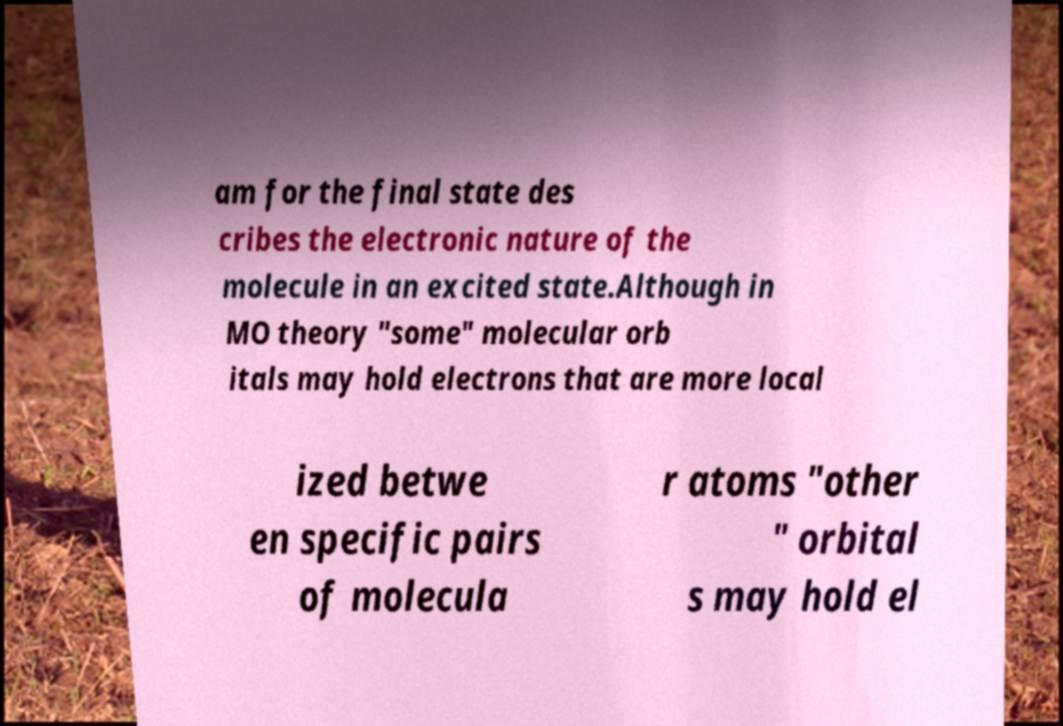Could you extract and type out the text from this image? am for the final state des cribes the electronic nature of the molecule in an excited state.Although in MO theory "some" molecular orb itals may hold electrons that are more local ized betwe en specific pairs of molecula r atoms "other " orbital s may hold el 